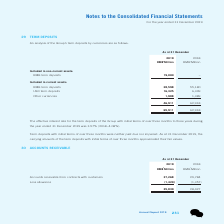According to Tencent's financial document, What was the effective interest rate for the Group's term deposits during the year ended 31 December 2019? According to the financial document, 3.57%. The relevant text states: "the year ended 31 December 2019 was 3.57% (2018: 4.08%)...." Also, What was the effective interest rate for the term deposits of the Group with initial terms of over three months to three years during the year ended 31 December 2018? According to the financial document, 4.08%. The relevant text states: "the year ended 31 December 2019 was 3.57% (2018: 4.08%)...." Also, How much was the RMB term deposits included in non-current assets as at 31 December 2019? According to the financial document, 19,000 (in millions). The relevant text states: "RMB term deposits 19,000 –..." Also, can you calculate: How much did the RMB term deposits included in current assets change by between 2018 year end and 2019 year end? Based on the calculation: 28,598-55,180, the result is -26582 (in millions). This is based on the information: "RMB term deposits 28,598 55,180 RMB term deposits 28,598 55,180..." The key data points involved are: 28,598, 55,180. Also, can you calculate: How much did the USD term deposits included in current assets change by between 2018 year end and 2019 year end? Based on the calculation: 16,325-6,349, the result is 9976 (in millions). This is based on the information: "USD term deposits 16,325 6,349 USD term deposits 16,325 6,349..." The key data points involved are: 16,325, 6,349. Also, can you calculate: How much did the total term deposits change by between 2018 year end and 2019 year end? Based on the calculation: 65,911-62,918, the result is 2993 (in millions). This is based on the information: "65,911 62,918 65,911 62,918..." The key data points involved are: 62,918, 65,911. 